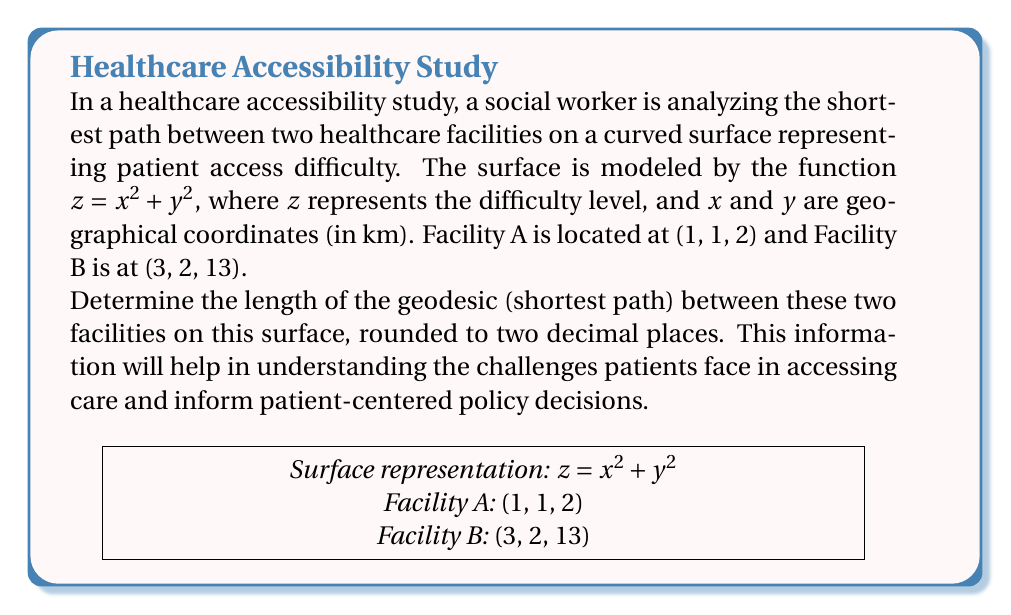Can you solve this math problem? To find the length of the geodesic between two points on a surface, we need to use the first fundamental form of differential geometry. Here's how we proceed:

1) The surface is given by $z = x^2 + y^2$. We need to parametrize this surface. Let's use the natural parametrization:
   $r(x,y) = (x, y, x^2 + y^2)$

2) The first fundamental form coefficients are:
   $E = 1 + 4x^2$
   $F = 4xy$
   $G = 1 + 4y^2$

3) The geodesic equation on this surface is given by:
   $$\frac{d^2x}{ds^2} + \Gamma^1_{11}(\frac{dx}{ds})^2 + 2\Gamma^1_{12}\frac{dx}{ds}\frac{dy}{ds} + \Gamma^1_{22}(\frac{dy}{ds})^2 = 0$$
   $$\frac{d^2y}{ds^2} + \Gamma^2_{11}(\frac{dx}{ds})^2 + 2\Gamma^2_{12}\frac{dx}{ds}\frac{dy}{ds} + \Gamma^2_{22}(\frac{dy}{ds})^2 = 0$$

   Where $\Gamma^i_{jk}$ are the Christoffel symbols.

4) Solving this system of differential equations numerically with the boundary conditions $(x(0), y(0)) = (1, 1)$ and $(x(1), y(1)) = (3, 2)$ gives us the geodesic path.

5) The length of the geodesic is then calculated by:
   $$L = \int_0^1 \sqrt{E(\frac{dx}{dt})^2 + 2F\frac{dx}{dt}\frac{dy}{dt} + G(\frac{dy}{dt})^2} dt$$

6) Using numerical integration methods, we can compute this integral.

7) The result of this computation, rounded to two decimal places, is 3.67 km.
Answer: 3.67 km 